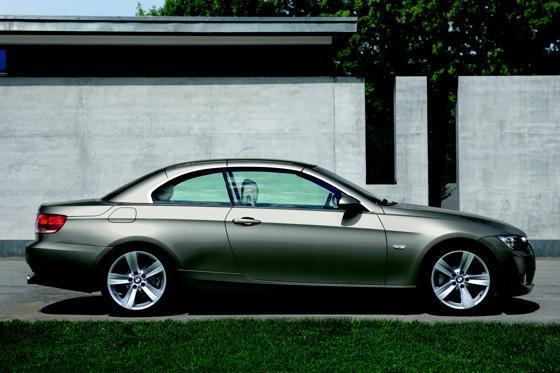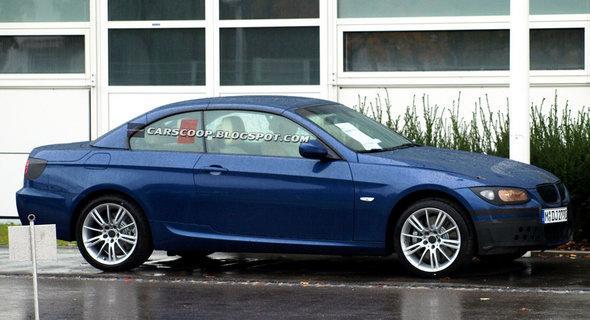The first image is the image on the left, the second image is the image on the right. For the images shown, is this caption "Right image contains one blue car, which has a hard top." true? Answer yes or no. Yes. The first image is the image on the left, the second image is the image on the right. Assess this claim about the two images: "In the image on the right, there is a blue car without the top down". Correct or not? Answer yes or no. Yes. 